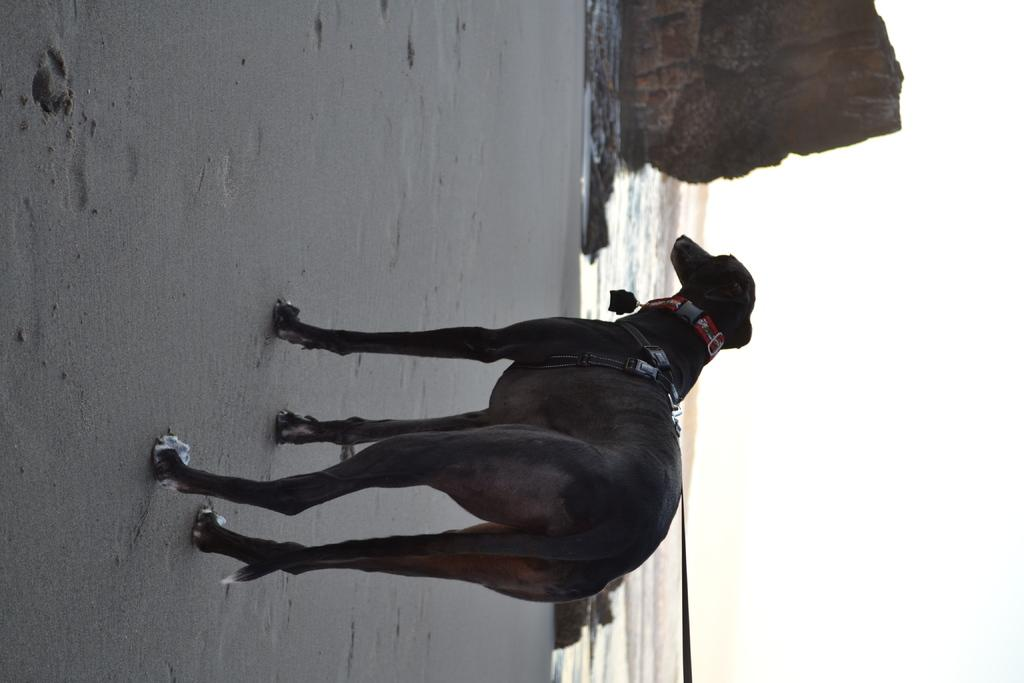What animal is present in the image? There is a dog in the image. Where is the dog located? The dog is on the sand. What can be seen on the left side of the image? There are rocks on the left side of the image. What is visible in the background of the image? There is water and the sky visible in the background of the image. What type of doll is sitting on the street in the image? There is no doll or street present in the image; it features a dog on the sand with rocks, water, and the sky visible in the background. 